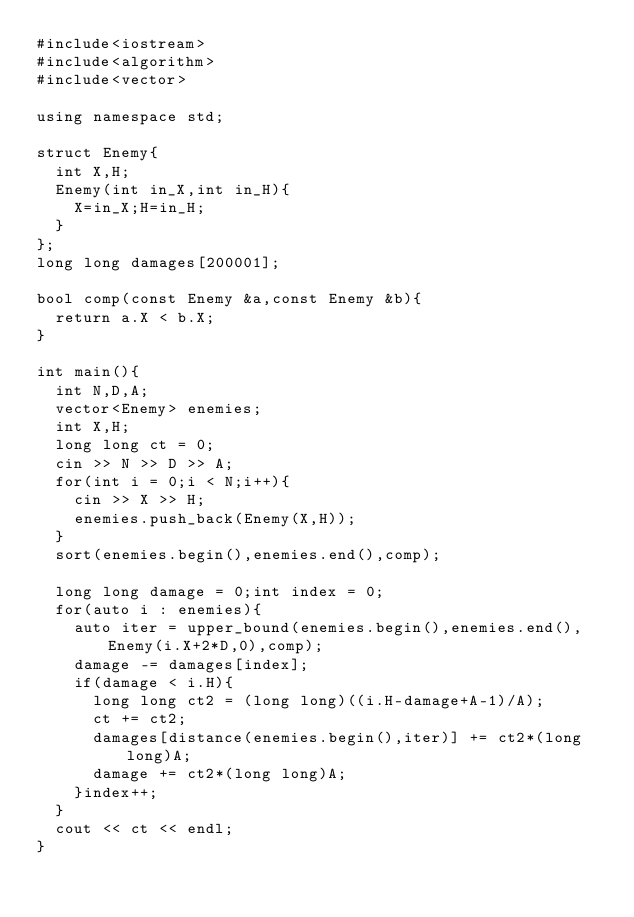<code> <loc_0><loc_0><loc_500><loc_500><_C++_>#include<iostream>
#include<algorithm>
#include<vector>

using namespace std;

struct Enemy{
  int X,H;
  Enemy(int in_X,int in_H){
    X=in_X;H=in_H;
  }
};
long long damages[200001];

bool comp(const Enemy &a,const Enemy &b){
  return a.X < b.X;
}

int main(){
  int N,D,A;
  vector<Enemy> enemies;
  int X,H;
  long long ct = 0;
  cin >> N >> D >> A;
  for(int i = 0;i < N;i++){
    cin >> X >> H;
    enemies.push_back(Enemy(X,H));
  }
  sort(enemies.begin(),enemies.end(),comp);
  
  long long damage = 0;int index = 0;
  for(auto i : enemies){
    auto iter = upper_bound(enemies.begin(),enemies.end(),Enemy(i.X+2*D,0),comp);
    damage -= damages[index];
    if(damage < i.H){
      long long ct2 = (long long)((i.H-damage+A-1)/A);
      ct += ct2;
      damages[distance(enemies.begin(),iter)] += ct2*(long long)A;
      damage += ct2*(long long)A;
    }index++;
  }
  cout << ct << endl;
}</code> 